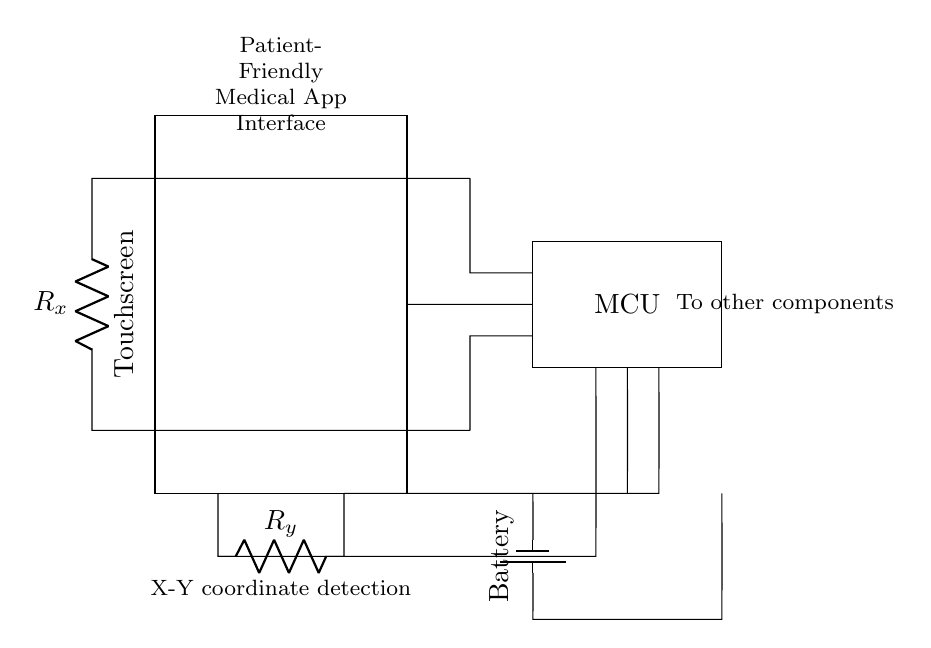What component is responsible for detecting touches? The touchscreen component is specifically designed to detect touches based on user interaction. It captures input from the user by sensing the pressure or touch location.
Answer: Touchscreen What does MCU stand for in this circuit? The term MCU in this context stands for Microcontroller Unit. It is the component that processes input from the touchscreen and performs necessary computations for the medical app interface.
Answer: Microcontroller Unit What type of sensors are represented by R_x and R_y? R_x and R_y are resistive sensors that measure the X and Y coordinates respectively on the touchscreen to determine the location of the touch.
Answer: Resistive sensors How does the battery connect to the touchscreen circuit? The battery is connected directly to the microcontroller unit. It provides the necessary voltage to power the entire circuit, including the touchscreen, to ensure it operates correctly.
Answer: Directly What is the function of the connections to the ADC inputs? The connections to the ADC inputs serve as the pathway for the analog signals from the resistive layers (R_x and R_y) to be converted into digital signals for processing by the microcontroller.
Answer: Signal conversion What does the label "X-Y coordinate detection" refer to? The label refers to the method by which the touchscreen determines the specific location of a touch by measuring the resistances (R_x and R_y) across the screen and calculating the coordinates.
Answer: Location measurement What additional components might be connected as indicated in the diagram? The diagram suggests the possibility of connecting other components for enhanced functionality such as speakers, additional sensors, or communication modules, which are typically integrated into mobile devices.
Answer: Other components 